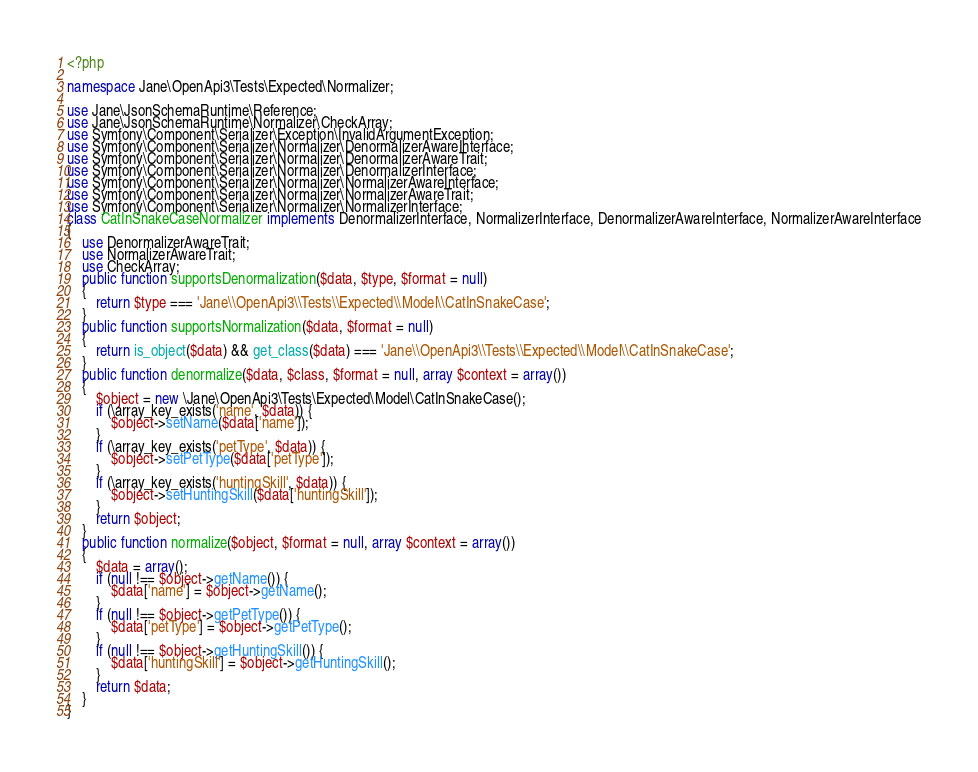Convert code to text. <code><loc_0><loc_0><loc_500><loc_500><_PHP_><?php

namespace Jane\OpenApi3\Tests\Expected\Normalizer;

use Jane\JsonSchemaRuntime\Reference;
use Jane\JsonSchemaRuntime\Normalizer\CheckArray;
use Symfony\Component\Serializer\Exception\InvalidArgumentException;
use Symfony\Component\Serializer\Normalizer\DenormalizerAwareInterface;
use Symfony\Component\Serializer\Normalizer\DenormalizerAwareTrait;
use Symfony\Component\Serializer\Normalizer\DenormalizerInterface;
use Symfony\Component\Serializer\Normalizer\NormalizerAwareInterface;
use Symfony\Component\Serializer\Normalizer\NormalizerAwareTrait;
use Symfony\Component\Serializer\Normalizer\NormalizerInterface;
class CatInSnakeCaseNormalizer implements DenormalizerInterface, NormalizerInterface, DenormalizerAwareInterface, NormalizerAwareInterface
{
    use DenormalizerAwareTrait;
    use NormalizerAwareTrait;
    use CheckArray;
    public function supportsDenormalization($data, $type, $format = null)
    {
        return $type === 'Jane\\OpenApi3\\Tests\\Expected\\Model\\CatInSnakeCase';
    }
    public function supportsNormalization($data, $format = null)
    {
        return is_object($data) && get_class($data) === 'Jane\\OpenApi3\\Tests\\Expected\\Model\\CatInSnakeCase';
    }
    public function denormalize($data, $class, $format = null, array $context = array())
    {
        $object = new \Jane\OpenApi3\Tests\Expected\Model\CatInSnakeCase();
        if (\array_key_exists('name', $data)) {
            $object->setName($data['name']);
        }
        if (\array_key_exists('petType', $data)) {
            $object->setPetType($data['petType']);
        }
        if (\array_key_exists('huntingSkill', $data)) {
            $object->setHuntingSkill($data['huntingSkill']);
        }
        return $object;
    }
    public function normalize($object, $format = null, array $context = array())
    {
        $data = array();
        if (null !== $object->getName()) {
            $data['name'] = $object->getName();
        }
        if (null !== $object->getPetType()) {
            $data['petType'] = $object->getPetType();
        }
        if (null !== $object->getHuntingSkill()) {
            $data['huntingSkill'] = $object->getHuntingSkill();
        }
        return $data;
    }
}</code> 